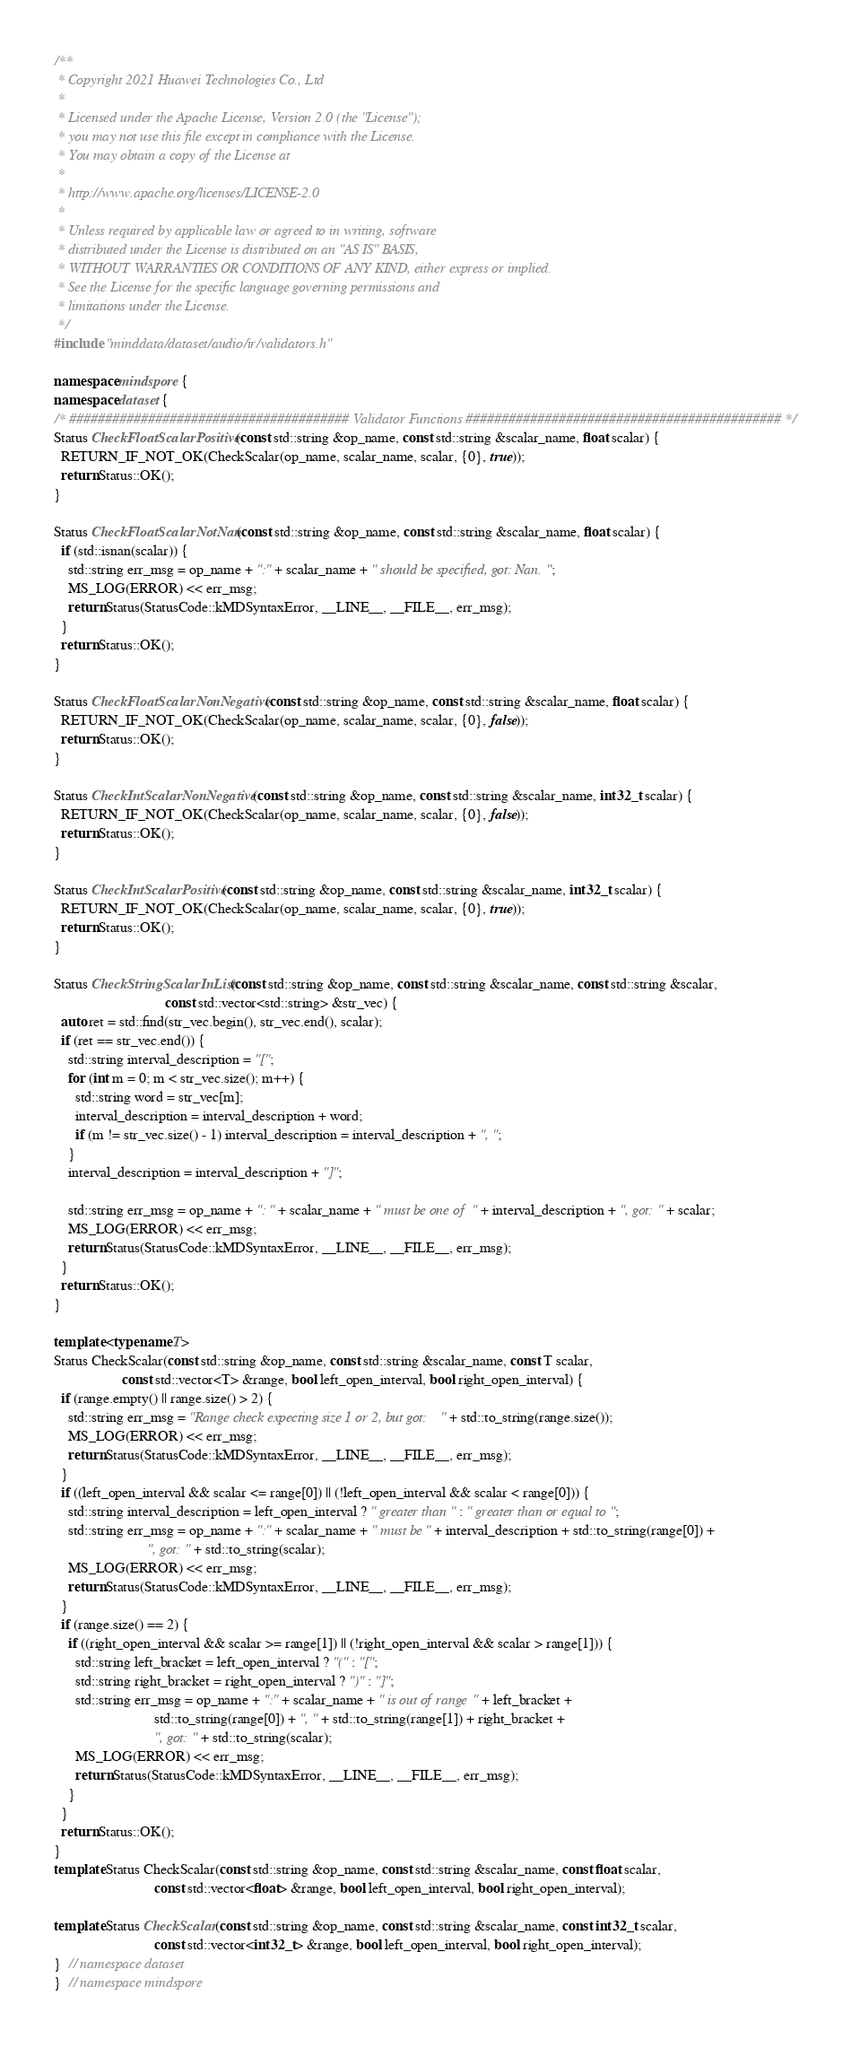<code> <loc_0><loc_0><loc_500><loc_500><_C++_>/**
 * Copyright 2021 Huawei Technologies Co., Ltd
 *
 * Licensed under the Apache License, Version 2.0 (the "License");
 * you may not use this file except in compliance with the License.
 * You may obtain a copy of the License at
 *
 * http://www.apache.org/licenses/LICENSE-2.0
 *
 * Unless required by applicable law or agreed to in writing, software
 * distributed under the License is distributed on an "AS IS" BASIS,
 * WITHOUT WARRANTIES OR CONDITIONS OF ANY KIND, either express or implied.
 * See the License for the specific language governing permissions and
 * limitations under the License.
 */
#include "minddata/dataset/audio/ir/validators.h"

namespace mindspore {
namespace dataset {
/* ####################################### Validator Functions ############################################ */
Status CheckFloatScalarPositive(const std::string &op_name, const std::string &scalar_name, float scalar) {
  RETURN_IF_NOT_OK(CheckScalar(op_name, scalar_name, scalar, {0}, true));
  return Status::OK();
}

Status CheckFloatScalarNotNan(const std::string &op_name, const std::string &scalar_name, float scalar) {
  if (std::isnan(scalar)) {
    std::string err_msg = op_name + ":" + scalar_name + " should be specified, got: Nan.";
    MS_LOG(ERROR) << err_msg;
    return Status(StatusCode::kMDSyntaxError, __LINE__, __FILE__, err_msg);
  }
  return Status::OK();
}

Status CheckFloatScalarNonNegative(const std::string &op_name, const std::string &scalar_name, float scalar) {
  RETURN_IF_NOT_OK(CheckScalar(op_name, scalar_name, scalar, {0}, false));
  return Status::OK();
}

Status CheckIntScalarNonNegative(const std::string &op_name, const std::string &scalar_name, int32_t scalar) {
  RETURN_IF_NOT_OK(CheckScalar(op_name, scalar_name, scalar, {0}, false));
  return Status::OK();
}

Status CheckIntScalarPositive(const std::string &op_name, const std::string &scalar_name, int32_t scalar) {
  RETURN_IF_NOT_OK(CheckScalar(op_name, scalar_name, scalar, {0}, true));
  return Status::OK();
}

Status CheckStringScalarInList(const std::string &op_name, const std::string &scalar_name, const std::string &scalar,
                               const std::vector<std::string> &str_vec) {
  auto ret = std::find(str_vec.begin(), str_vec.end(), scalar);
  if (ret == str_vec.end()) {
    std::string interval_description = "[";
    for (int m = 0; m < str_vec.size(); m++) {
      std::string word = str_vec[m];
      interval_description = interval_description + word;
      if (m != str_vec.size() - 1) interval_description = interval_description + ", ";
    }
    interval_description = interval_description + "]";

    std::string err_msg = op_name + ": " + scalar_name + " must be one of " + interval_description + ", got: " + scalar;
    MS_LOG(ERROR) << err_msg;
    return Status(StatusCode::kMDSyntaxError, __LINE__, __FILE__, err_msg);
  }
  return Status::OK();
}

template <typename T>
Status CheckScalar(const std::string &op_name, const std::string &scalar_name, const T scalar,
                   const std::vector<T> &range, bool left_open_interval, bool right_open_interval) {
  if (range.empty() || range.size() > 2) {
    std::string err_msg = "Range check expecting size 1 or 2, but got: " + std::to_string(range.size());
    MS_LOG(ERROR) << err_msg;
    return Status(StatusCode::kMDSyntaxError, __LINE__, __FILE__, err_msg);
  }
  if ((left_open_interval && scalar <= range[0]) || (!left_open_interval && scalar < range[0])) {
    std::string interval_description = left_open_interval ? " greater than " : " greater than or equal to ";
    std::string err_msg = op_name + ":" + scalar_name + " must be" + interval_description + std::to_string(range[0]) +
                          ", got: " + std::to_string(scalar);
    MS_LOG(ERROR) << err_msg;
    return Status(StatusCode::kMDSyntaxError, __LINE__, __FILE__, err_msg);
  }
  if (range.size() == 2) {
    if ((right_open_interval && scalar >= range[1]) || (!right_open_interval && scalar > range[1])) {
      std::string left_bracket = left_open_interval ? "(" : "[";
      std::string right_bracket = right_open_interval ? ")" : "]";
      std::string err_msg = op_name + ":" + scalar_name + " is out of range " + left_bracket +
                            std::to_string(range[0]) + ", " + std::to_string(range[1]) + right_bracket +
                            ", got: " + std::to_string(scalar);
      MS_LOG(ERROR) << err_msg;
      return Status(StatusCode::kMDSyntaxError, __LINE__, __FILE__, err_msg);
    }
  }
  return Status::OK();
}
template Status CheckScalar(const std::string &op_name, const std::string &scalar_name, const float scalar,
                            const std::vector<float> &range, bool left_open_interval, bool right_open_interval);

template Status CheckScalar(const std::string &op_name, const std::string &scalar_name, const int32_t scalar,
                            const std::vector<int32_t> &range, bool left_open_interval, bool right_open_interval);
}  // namespace dataset
}  // namespace mindspore
</code> 